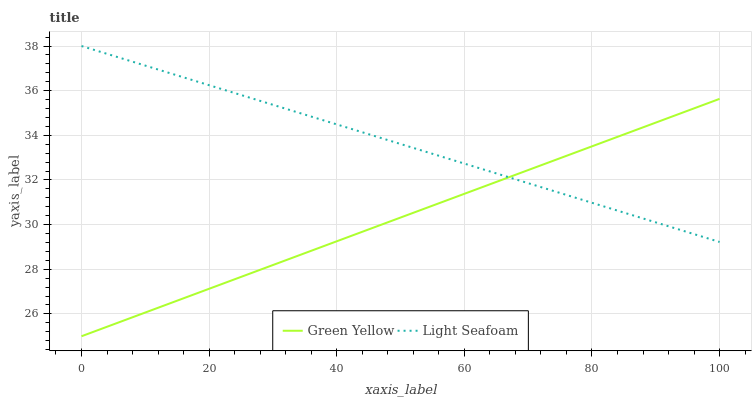Does Green Yellow have the minimum area under the curve?
Answer yes or no. Yes. Does Light Seafoam have the maximum area under the curve?
Answer yes or no. Yes. Does Light Seafoam have the minimum area under the curve?
Answer yes or no. No. Is Green Yellow the smoothest?
Answer yes or no. Yes. Is Light Seafoam the roughest?
Answer yes or no. Yes. Is Light Seafoam the smoothest?
Answer yes or no. No. Does Green Yellow have the lowest value?
Answer yes or no. Yes. Does Light Seafoam have the lowest value?
Answer yes or no. No. Does Light Seafoam have the highest value?
Answer yes or no. Yes. Does Green Yellow intersect Light Seafoam?
Answer yes or no. Yes. Is Green Yellow less than Light Seafoam?
Answer yes or no. No. Is Green Yellow greater than Light Seafoam?
Answer yes or no. No. 